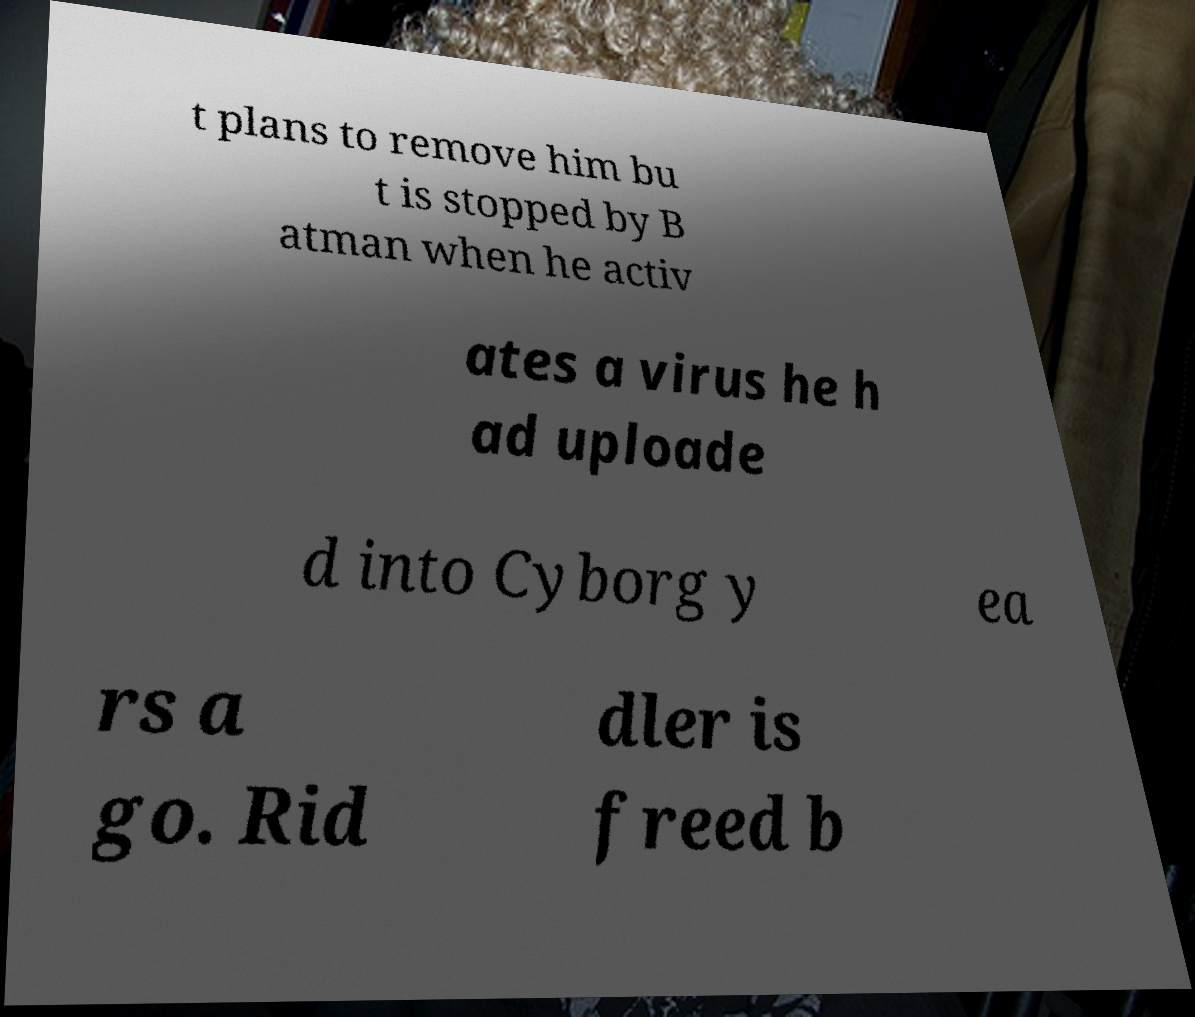I need the written content from this picture converted into text. Can you do that? t plans to remove him bu t is stopped by B atman when he activ ates a virus he h ad uploade d into Cyborg y ea rs a go. Rid dler is freed b 